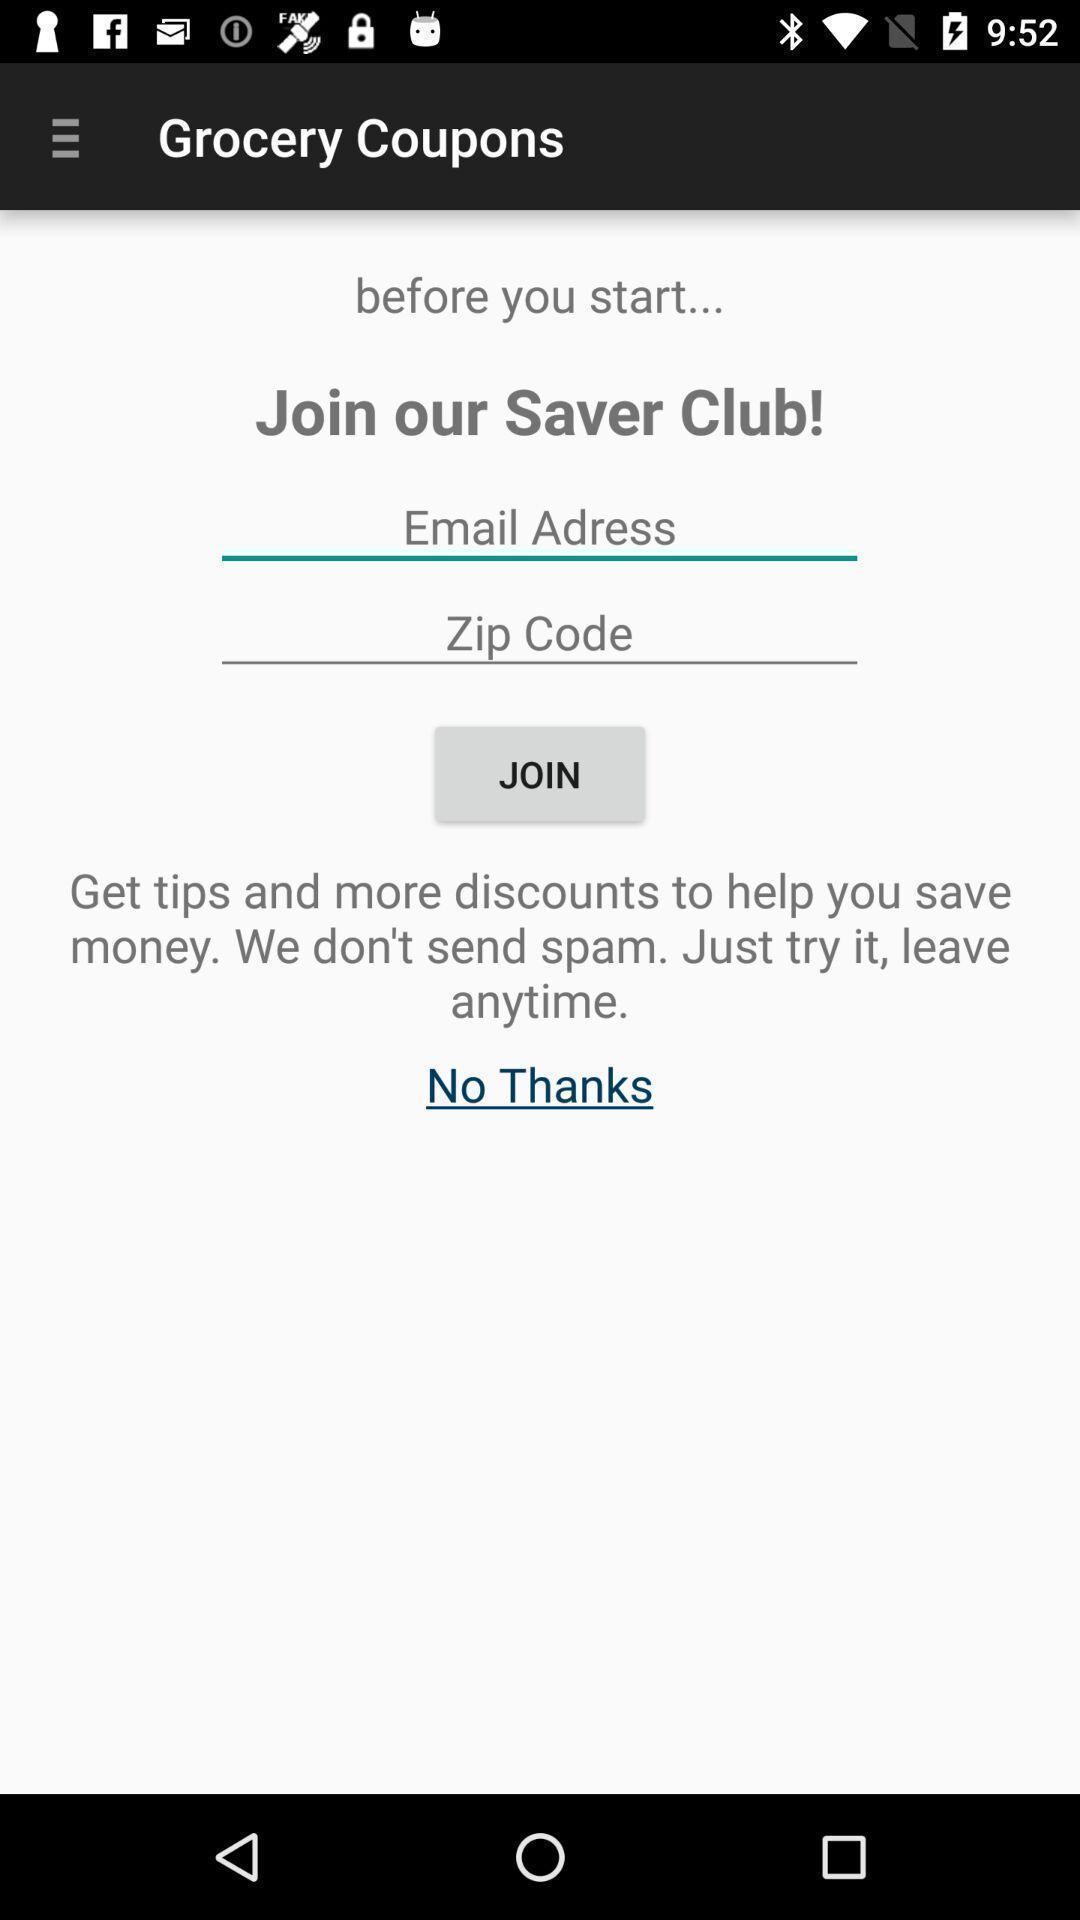Describe the key features of this screenshot. Screen shows grocery coupons with multiple options. 